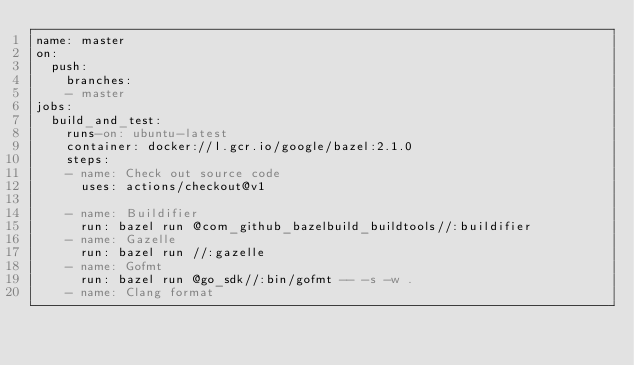Convert code to text. <code><loc_0><loc_0><loc_500><loc_500><_YAML_>name: master
on:
  push:
    branches:
    - master
jobs:
  build_and_test:
    runs-on: ubuntu-latest
    container: docker://l.gcr.io/google/bazel:2.1.0
    steps:
    - name: Check out source code
      uses: actions/checkout@v1

    - name: Buildifier
      run: bazel run @com_github_bazelbuild_buildtools//:buildifier
    - name: Gazelle
      run: bazel run //:gazelle
    - name: Gofmt
      run: bazel run @go_sdk//:bin/gofmt -- -s -w .
    - name: Clang format</code> 